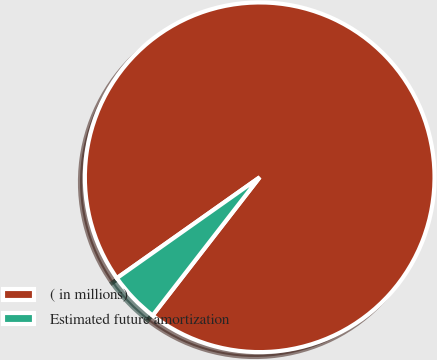<chart> <loc_0><loc_0><loc_500><loc_500><pie_chart><fcel>( in millions)<fcel>Estimated future amortization<nl><fcel>95.28%<fcel>4.72%<nl></chart> 